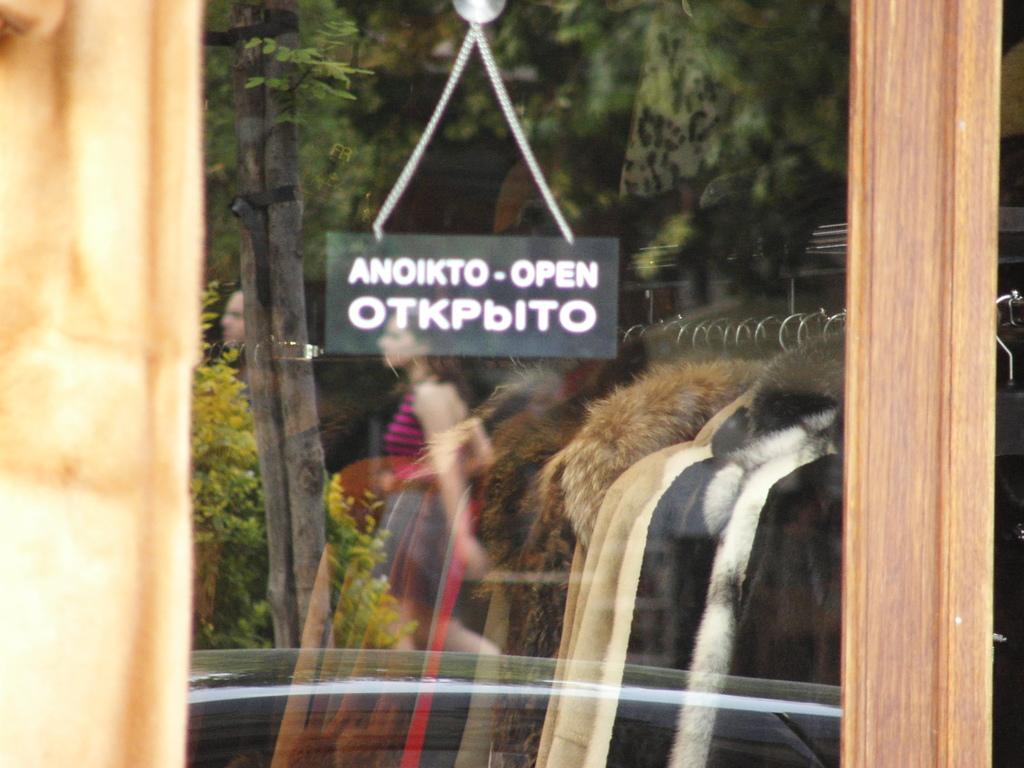What is the main object in the center of the image? There is a mirror in the center of the image. What does the mirror reflect in the image? The mirror reflects a woman and trees in the image. What type of clothing can be seen in the image? There are jackets in the image. What is on the left side of the image? There is a wooden frame on the left side of the image. What type of gold jewelry is the monkey wearing in the image? There is no monkey or gold jewelry present in the image. 